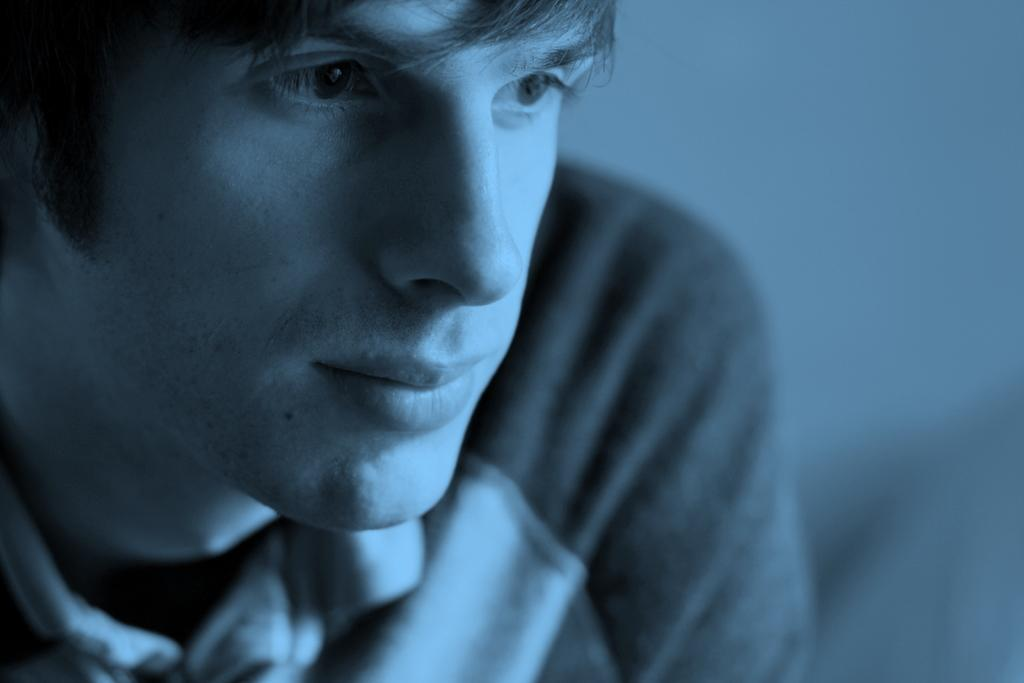What is present in the image? There is a person in the image. What is the person wearing? The person is wearing a T-shirt. Can you describe the quality of the image? The image is slightly blurred. What is the name of the person's son in the image? There is no mention of a son or any family members in the image, so we cannot determine the name of the person's son. 